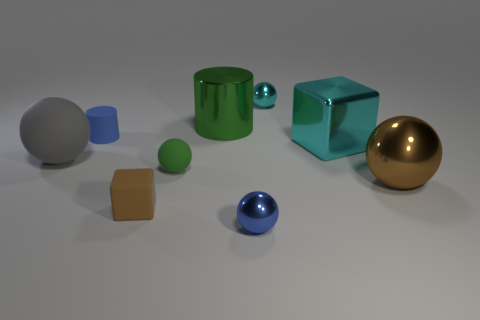Subtract 1 balls. How many balls are left? 4 Subtract all cyan metal spheres. How many spheres are left? 4 Subtract all red balls. Subtract all blue cylinders. How many balls are left? 5 Subtract all cubes. How many objects are left? 7 Add 5 small metallic spheres. How many small metallic spheres exist? 7 Subtract 0 red cylinders. How many objects are left? 9 Subtract all rubber things. Subtract all tiny yellow cylinders. How many objects are left? 5 Add 3 blue shiny balls. How many blue shiny balls are left? 4 